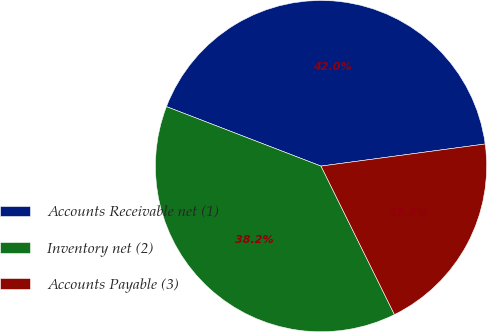<chart> <loc_0><loc_0><loc_500><loc_500><pie_chart><fcel>Accounts Receivable net (1)<fcel>Inventory net (2)<fcel>Accounts Payable (3)<nl><fcel>42.02%<fcel>38.16%<fcel>19.82%<nl></chart> 